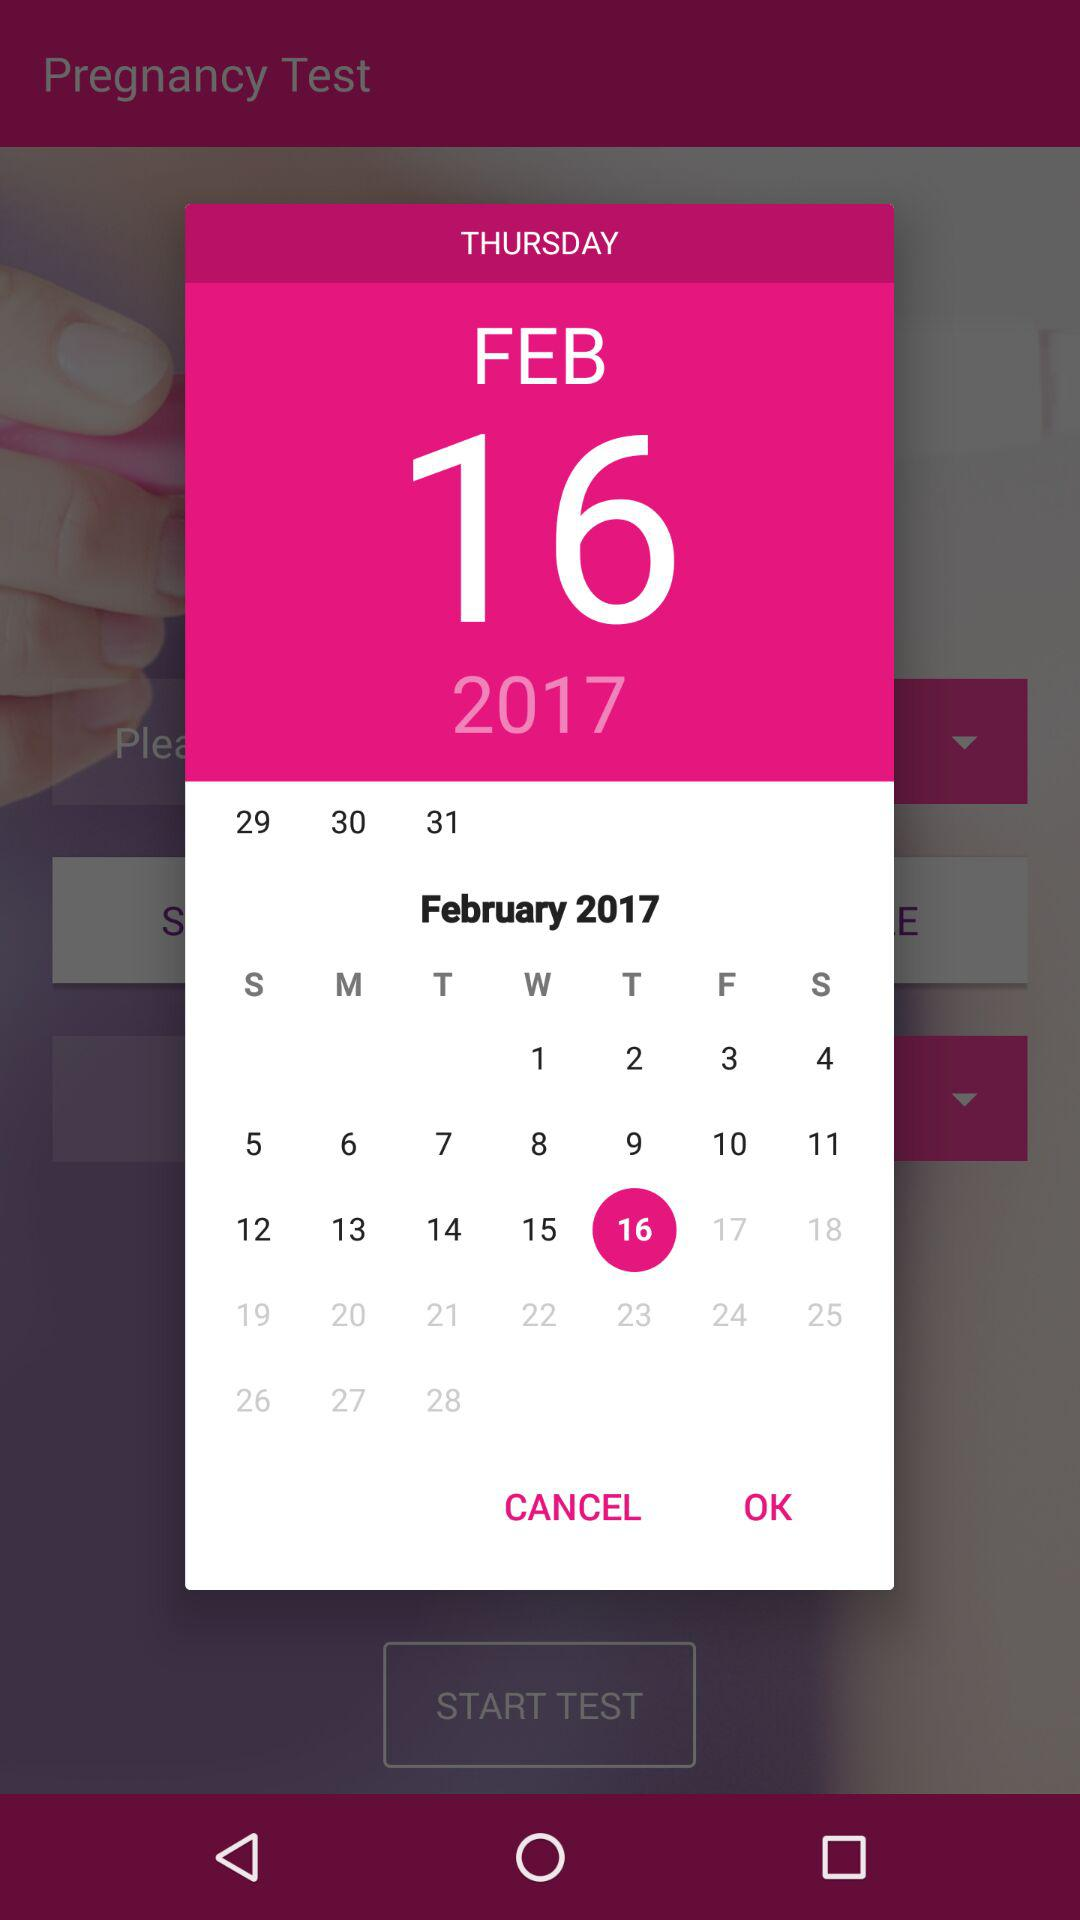What is the selected date? The selected date is Thursday, February 16, 2017. 